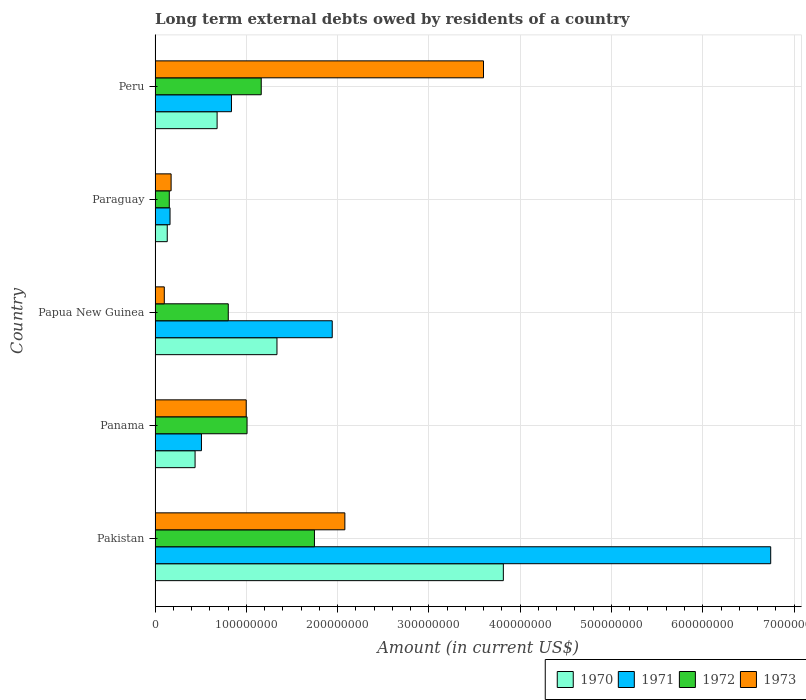How many different coloured bars are there?
Your answer should be very brief. 4. How many bars are there on the 3rd tick from the top?
Provide a succinct answer. 4. How many bars are there on the 3rd tick from the bottom?
Provide a succinct answer. 4. What is the label of the 2nd group of bars from the top?
Your response must be concise. Paraguay. What is the amount of long-term external debts owed by residents in 1973 in Paraguay?
Give a very brief answer. 1.76e+07. Across all countries, what is the maximum amount of long-term external debts owed by residents in 1970?
Give a very brief answer. 3.82e+08. Across all countries, what is the minimum amount of long-term external debts owed by residents in 1973?
Your answer should be compact. 1.01e+07. In which country was the amount of long-term external debts owed by residents in 1973 maximum?
Provide a succinct answer. Peru. In which country was the amount of long-term external debts owed by residents in 1972 minimum?
Your answer should be very brief. Paraguay. What is the total amount of long-term external debts owed by residents in 1972 in the graph?
Give a very brief answer. 4.87e+08. What is the difference between the amount of long-term external debts owed by residents in 1970 in Panama and that in Peru?
Your response must be concise. -2.41e+07. What is the difference between the amount of long-term external debts owed by residents in 1973 in Paraguay and the amount of long-term external debts owed by residents in 1972 in Pakistan?
Your response must be concise. -1.57e+08. What is the average amount of long-term external debts owed by residents in 1970 per country?
Provide a succinct answer. 1.28e+08. What is the difference between the amount of long-term external debts owed by residents in 1970 and amount of long-term external debts owed by residents in 1972 in Peru?
Keep it short and to the point. -4.83e+07. In how many countries, is the amount of long-term external debts owed by residents in 1973 greater than 380000000 US$?
Make the answer very short. 0. What is the ratio of the amount of long-term external debts owed by residents in 1970 in Panama to that in Peru?
Give a very brief answer. 0.64. Is the amount of long-term external debts owed by residents in 1970 in Panama less than that in Paraguay?
Offer a very short reply. No. Is the difference between the amount of long-term external debts owed by residents in 1970 in Pakistan and Papua New Guinea greater than the difference between the amount of long-term external debts owed by residents in 1972 in Pakistan and Papua New Guinea?
Provide a short and direct response. Yes. What is the difference between the highest and the second highest amount of long-term external debts owed by residents in 1971?
Your response must be concise. 4.80e+08. What is the difference between the highest and the lowest amount of long-term external debts owed by residents in 1970?
Offer a terse response. 3.68e+08. What does the 3rd bar from the top in Panama represents?
Provide a succinct answer. 1971. What does the 1st bar from the bottom in Paraguay represents?
Offer a very short reply. 1970. Are all the bars in the graph horizontal?
Offer a very short reply. Yes. What is the difference between two consecutive major ticks on the X-axis?
Make the answer very short. 1.00e+08. Does the graph contain any zero values?
Your answer should be very brief. No. Does the graph contain grids?
Offer a terse response. Yes. Where does the legend appear in the graph?
Offer a terse response. Bottom right. How many legend labels are there?
Your response must be concise. 4. How are the legend labels stacked?
Offer a terse response. Horizontal. What is the title of the graph?
Your answer should be very brief. Long term external debts owed by residents of a country. What is the label or title of the X-axis?
Provide a succinct answer. Amount (in current US$). What is the label or title of the Y-axis?
Make the answer very short. Country. What is the Amount (in current US$) in 1970 in Pakistan?
Provide a succinct answer. 3.82e+08. What is the Amount (in current US$) in 1971 in Pakistan?
Give a very brief answer. 6.74e+08. What is the Amount (in current US$) of 1972 in Pakistan?
Offer a very short reply. 1.75e+08. What is the Amount (in current US$) of 1973 in Pakistan?
Ensure brevity in your answer.  2.08e+08. What is the Amount (in current US$) in 1970 in Panama?
Provide a short and direct response. 4.38e+07. What is the Amount (in current US$) of 1971 in Panama?
Keep it short and to the point. 5.08e+07. What is the Amount (in current US$) in 1972 in Panama?
Give a very brief answer. 1.01e+08. What is the Amount (in current US$) in 1973 in Panama?
Your answer should be compact. 9.99e+07. What is the Amount (in current US$) in 1970 in Papua New Guinea?
Offer a very short reply. 1.34e+08. What is the Amount (in current US$) of 1971 in Papua New Guinea?
Your answer should be very brief. 1.94e+08. What is the Amount (in current US$) of 1972 in Papua New Guinea?
Your answer should be compact. 8.02e+07. What is the Amount (in current US$) in 1973 in Papua New Guinea?
Offer a very short reply. 1.01e+07. What is the Amount (in current US$) in 1970 in Paraguay?
Your answer should be compact. 1.34e+07. What is the Amount (in current US$) in 1971 in Paraguay?
Offer a terse response. 1.64e+07. What is the Amount (in current US$) of 1972 in Paraguay?
Provide a short and direct response. 1.56e+07. What is the Amount (in current US$) in 1973 in Paraguay?
Ensure brevity in your answer.  1.76e+07. What is the Amount (in current US$) of 1970 in Peru?
Your answer should be very brief. 6.80e+07. What is the Amount (in current US$) in 1971 in Peru?
Provide a succinct answer. 8.37e+07. What is the Amount (in current US$) of 1972 in Peru?
Your answer should be compact. 1.16e+08. What is the Amount (in current US$) of 1973 in Peru?
Offer a terse response. 3.60e+08. Across all countries, what is the maximum Amount (in current US$) of 1970?
Give a very brief answer. 3.82e+08. Across all countries, what is the maximum Amount (in current US$) of 1971?
Your response must be concise. 6.74e+08. Across all countries, what is the maximum Amount (in current US$) of 1972?
Give a very brief answer. 1.75e+08. Across all countries, what is the maximum Amount (in current US$) of 1973?
Provide a short and direct response. 3.60e+08. Across all countries, what is the minimum Amount (in current US$) of 1970?
Your answer should be very brief. 1.34e+07. Across all countries, what is the minimum Amount (in current US$) in 1971?
Offer a terse response. 1.64e+07. Across all countries, what is the minimum Amount (in current US$) of 1972?
Keep it short and to the point. 1.56e+07. Across all countries, what is the minimum Amount (in current US$) in 1973?
Offer a very short reply. 1.01e+07. What is the total Amount (in current US$) in 1970 in the graph?
Your answer should be compact. 6.40e+08. What is the total Amount (in current US$) in 1971 in the graph?
Keep it short and to the point. 1.02e+09. What is the total Amount (in current US$) of 1972 in the graph?
Provide a short and direct response. 4.87e+08. What is the total Amount (in current US$) of 1973 in the graph?
Offer a very short reply. 6.95e+08. What is the difference between the Amount (in current US$) of 1970 in Pakistan and that in Panama?
Offer a terse response. 3.38e+08. What is the difference between the Amount (in current US$) of 1971 in Pakistan and that in Panama?
Keep it short and to the point. 6.24e+08. What is the difference between the Amount (in current US$) in 1972 in Pakistan and that in Panama?
Your response must be concise. 7.38e+07. What is the difference between the Amount (in current US$) in 1973 in Pakistan and that in Panama?
Provide a succinct answer. 1.08e+08. What is the difference between the Amount (in current US$) in 1970 in Pakistan and that in Papua New Guinea?
Ensure brevity in your answer.  2.48e+08. What is the difference between the Amount (in current US$) of 1971 in Pakistan and that in Papua New Guinea?
Keep it short and to the point. 4.80e+08. What is the difference between the Amount (in current US$) in 1972 in Pakistan and that in Papua New Guinea?
Keep it short and to the point. 9.44e+07. What is the difference between the Amount (in current US$) of 1973 in Pakistan and that in Papua New Guinea?
Your response must be concise. 1.98e+08. What is the difference between the Amount (in current US$) of 1970 in Pakistan and that in Paraguay?
Your answer should be very brief. 3.68e+08. What is the difference between the Amount (in current US$) in 1971 in Pakistan and that in Paraguay?
Ensure brevity in your answer.  6.58e+08. What is the difference between the Amount (in current US$) in 1972 in Pakistan and that in Paraguay?
Give a very brief answer. 1.59e+08. What is the difference between the Amount (in current US$) of 1973 in Pakistan and that in Paraguay?
Your answer should be very brief. 1.90e+08. What is the difference between the Amount (in current US$) of 1970 in Pakistan and that in Peru?
Provide a short and direct response. 3.14e+08. What is the difference between the Amount (in current US$) in 1971 in Pakistan and that in Peru?
Ensure brevity in your answer.  5.91e+08. What is the difference between the Amount (in current US$) in 1972 in Pakistan and that in Peru?
Make the answer very short. 5.83e+07. What is the difference between the Amount (in current US$) of 1973 in Pakistan and that in Peru?
Your answer should be compact. -1.52e+08. What is the difference between the Amount (in current US$) in 1970 in Panama and that in Papua New Guinea?
Your response must be concise. -8.97e+07. What is the difference between the Amount (in current US$) of 1971 in Panama and that in Papua New Guinea?
Your response must be concise. -1.43e+08. What is the difference between the Amount (in current US$) of 1972 in Panama and that in Papua New Guinea?
Keep it short and to the point. 2.06e+07. What is the difference between the Amount (in current US$) of 1973 in Panama and that in Papua New Guinea?
Give a very brief answer. 8.97e+07. What is the difference between the Amount (in current US$) in 1970 in Panama and that in Paraguay?
Make the answer very short. 3.05e+07. What is the difference between the Amount (in current US$) in 1971 in Panama and that in Paraguay?
Make the answer very short. 3.44e+07. What is the difference between the Amount (in current US$) in 1972 in Panama and that in Paraguay?
Provide a succinct answer. 8.52e+07. What is the difference between the Amount (in current US$) in 1973 in Panama and that in Paraguay?
Provide a short and direct response. 8.23e+07. What is the difference between the Amount (in current US$) in 1970 in Panama and that in Peru?
Provide a succinct answer. -2.41e+07. What is the difference between the Amount (in current US$) in 1971 in Panama and that in Peru?
Make the answer very short. -3.29e+07. What is the difference between the Amount (in current US$) in 1972 in Panama and that in Peru?
Your response must be concise. -1.56e+07. What is the difference between the Amount (in current US$) in 1973 in Panama and that in Peru?
Give a very brief answer. -2.60e+08. What is the difference between the Amount (in current US$) of 1970 in Papua New Guinea and that in Paraguay?
Your answer should be compact. 1.20e+08. What is the difference between the Amount (in current US$) in 1971 in Papua New Guinea and that in Paraguay?
Offer a terse response. 1.78e+08. What is the difference between the Amount (in current US$) of 1972 in Papua New Guinea and that in Paraguay?
Keep it short and to the point. 6.46e+07. What is the difference between the Amount (in current US$) in 1973 in Papua New Guinea and that in Paraguay?
Your response must be concise. -7.47e+06. What is the difference between the Amount (in current US$) in 1970 in Papua New Guinea and that in Peru?
Make the answer very short. 6.56e+07. What is the difference between the Amount (in current US$) in 1971 in Papua New Guinea and that in Peru?
Provide a succinct answer. 1.10e+08. What is the difference between the Amount (in current US$) of 1972 in Papua New Guinea and that in Peru?
Provide a succinct answer. -3.61e+07. What is the difference between the Amount (in current US$) of 1973 in Papua New Guinea and that in Peru?
Provide a succinct answer. -3.50e+08. What is the difference between the Amount (in current US$) of 1970 in Paraguay and that in Peru?
Make the answer very short. -5.46e+07. What is the difference between the Amount (in current US$) of 1971 in Paraguay and that in Peru?
Give a very brief answer. -6.73e+07. What is the difference between the Amount (in current US$) of 1972 in Paraguay and that in Peru?
Offer a very short reply. -1.01e+08. What is the difference between the Amount (in current US$) in 1973 in Paraguay and that in Peru?
Your response must be concise. -3.42e+08. What is the difference between the Amount (in current US$) of 1970 in Pakistan and the Amount (in current US$) of 1971 in Panama?
Make the answer very short. 3.31e+08. What is the difference between the Amount (in current US$) in 1970 in Pakistan and the Amount (in current US$) in 1972 in Panama?
Your response must be concise. 2.81e+08. What is the difference between the Amount (in current US$) of 1970 in Pakistan and the Amount (in current US$) of 1973 in Panama?
Offer a very short reply. 2.82e+08. What is the difference between the Amount (in current US$) in 1971 in Pakistan and the Amount (in current US$) in 1972 in Panama?
Give a very brief answer. 5.74e+08. What is the difference between the Amount (in current US$) in 1971 in Pakistan and the Amount (in current US$) in 1973 in Panama?
Provide a succinct answer. 5.75e+08. What is the difference between the Amount (in current US$) of 1972 in Pakistan and the Amount (in current US$) of 1973 in Panama?
Your response must be concise. 7.47e+07. What is the difference between the Amount (in current US$) in 1970 in Pakistan and the Amount (in current US$) in 1971 in Papua New Guinea?
Keep it short and to the point. 1.87e+08. What is the difference between the Amount (in current US$) in 1970 in Pakistan and the Amount (in current US$) in 1972 in Papua New Guinea?
Provide a succinct answer. 3.01e+08. What is the difference between the Amount (in current US$) of 1970 in Pakistan and the Amount (in current US$) of 1973 in Papua New Guinea?
Your answer should be compact. 3.71e+08. What is the difference between the Amount (in current US$) in 1971 in Pakistan and the Amount (in current US$) in 1972 in Papua New Guinea?
Offer a very short reply. 5.94e+08. What is the difference between the Amount (in current US$) of 1971 in Pakistan and the Amount (in current US$) of 1973 in Papua New Guinea?
Provide a short and direct response. 6.64e+08. What is the difference between the Amount (in current US$) in 1972 in Pakistan and the Amount (in current US$) in 1973 in Papua New Guinea?
Provide a succinct answer. 1.64e+08. What is the difference between the Amount (in current US$) in 1970 in Pakistan and the Amount (in current US$) in 1971 in Paraguay?
Keep it short and to the point. 3.65e+08. What is the difference between the Amount (in current US$) in 1970 in Pakistan and the Amount (in current US$) in 1972 in Paraguay?
Offer a terse response. 3.66e+08. What is the difference between the Amount (in current US$) of 1970 in Pakistan and the Amount (in current US$) of 1973 in Paraguay?
Provide a succinct answer. 3.64e+08. What is the difference between the Amount (in current US$) of 1971 in Pakistan and the Amount (in current US$) of 1972 in Paraguay?
Your response must be concise. 6.59e+08. What is the difference between the Amount (in current US$) of 1971 in Pakistan and the Amount (in current US$) of 1973 in Paraguay?
Your answer should be very brief. 6.57e+08. What is the difference between the Amount (in current US$) of 1972 in Pakistan and the Amount (in current US$) of 1973 in Paraguay?
Provide a succinct answer. 1.57e+08. What is the difference between the Amount (in current US$) in 1970 in Pakistan and the Amount (in current US$) in 1971 in Peru?
Make the answer very short. 2.98e+08. What is the difference between the Amount (in current US$) in 1970 in Pakistan and the Amount (in current US$) in 1972 in Peru?
Provide a short and direct response. 2.65e+08. What is the difference between the Amount (in current US$) of 1970 in Pakistan and the Amount (in current US$) of 1973 in Peru?
Provide a short and direct response. 2.17e+07. What is the difference between the Amount (in current US$) of 1971 in Pakistan and the Amount (in current US$) of 1972 in Peru?
Keep it short and to the point. 5.58e+08. What is the difference between the Amount (in current US$) in 1971 in Pakistan and the Amount (in current US$) in 1973 in Peru?
Give a very brief answer. 3.15e+08. What is the difference between the Amount (in current US$) in 1972 in Pakistan and the Amount (in current US$) in 1973 in Peru?
Offer a very short reply. -1.85e+08. What is the difference between the Amount (in current US$) in 1970 in Panama and the Amount (in current US$) in 1971 in Papua New Guinea?
Ensure brevity in your answer.  -1.50e+08. What is the difference between the Amount (in current US$) in 1970 in Panama and the Amount (in current US$) in 1972 in Papua New Guinea?
Your answer should be compact. -3.64e+07. What is the difference between the Amount (in current US$) in 1970 in Panama and the Amount (in current US$) in 1973 in Papua New Guinea?
Your answer should be very brief. 3.37e+07. What is the difference between the Amount (in current US$) in 1971 in Panama and the Amount (in current US$) in 1972 in Papua New Guinea?
Provide a short and direct response. -2.94e+07. What is the difference between the Amount (in current US$) in 1971 in Panama and the Amount (in current US$) in 1973 in Papua New Guinea?
Make the answer very short. 4.07e+07. What is the difference between the Amount (in current US$) of 1972 in Panama and the Amount (in current US$) of 1973 in Papua New Guinea?
Provide a succinct answer. 9.06e+07. What is the difference between the Amount (in current US$) in 1970 in Panama and the Amount (in current US$) in 1971 in Paraguay?
Keep it short and to the point. 2.74e+07. What is the difference between the Amount (in current US$) of 1970 in Panama and the Amount (in current US$) of 1972 in Paraguay?
Make the answer very short. 2.82e+07. What is the difference between the Amount (in current US$) in 1970 in Panama and the Amount (in current US$) in 1973 in Paraguay?
Offer a terse response. 2.62e+07. What is the difference between the Amount (in current US$) in 1971 in Panama and the Amount (in current US$) in 1972 in Paraguay?
Give a very brief answer. 3.52e+07. What is the difference between the Amount (in current US$) of 1971 in Panama and the Amount (in current US$) of 1973 in Paraguay?
Make the answer very short. 3.32e+07. What is the difference between the Amount (in current US$) in 1972 in Panama and the Amount (in current US$) in 1973 in Paraguay?
Keep it short and to the point. 8.32e+07. What is the difference between the Amount (in current US$) of 1970 in Panama and the Amount (in current US$) of 1971 in Peru?
Ensure brevity in your answer.  -3.99e+07. What is the difference between the Amount (in current US$) in 1970 in Panama and the Amount (in current US$) in 1972 in Peru?
Your answer should be very brief. -7.25e+07. What is the difference between the Amount (in current US$) in 1970 in Panama and the Amount (in current US$) in 1973 in Peru?
Your answer should be compact. -3.16e+08. What is the difference between the Amount (in current US$) of 1971 in Panama and the Amount (in current US$) of 1972 in Peru?
Offer a terse response. -6.55e+07. What is the difference between the Amount (in current US$) of 1971 in Panama and the Amount (in current US$) of 1973 in Peru?
Your answer should be compact. -3.09e+08. What is the difference between the Amount (in current US$) in 1972 in Panama and the Amount (in current US$) in 1973 in Peru?
Your answer should be compact. -2.59e+08. What is the difference between the Amount (in current US$) of 1970 in Papua New Guinea and the Amount (in current US$) of 1971 in Paraguay?
Provide a succinct answer. 1.17e+08. What is the difference between the Amount (in current US$) in 1970 in Papua New Guinea and the Amount (in current US$) in 1972 in Paraguay?
Your response must be concise. 1.18e+08. What is the difference between the Amount (in current US$) of 1970 in Papua New Guinea and the Amount (in current US$) of 1973 in Paraguay?
Your response must be concise. 1.16e+08. What is the difference between the Amount (in current US$) in 1971 in Papua New Guinea and the Amount (in current US$) in 1972 in Paraguay?
Keep it short and to the point. 1.78e+08. What is the difference between the Amount (in current US$) of 1971 in Papua New Guinea and the Amount (in current US$) of 1973 in Paraguay?
Give a very brief answer. 1.77e+08. What is the difference between the Amount (in current US$) in 1972 in Papua New Guinea and the Amount (in current US$) in 1973 in Paraguay?
Offer a very short reply. 6.26e+07. What is the difference between the Amount (in current US$) of 1970 in Papua New Guinea and the Amount (in current US$) of 1971 in Peru?
Make the answer very short. 4.98e+07. What is the difference between the Amount (in current US$) in 1970 in Papua New Guinea and the Amount (in current US$) in 1972 in Peru?
Make the answer very short. 1.72e+07. What is the difference between the Amount (in current US$) of 1970 in Papua New Guinea and the Amount (in current US$) of 1973 in Peru?
Offer a terse response. -2.26e+08. What is the difference between the Amount (in current US$) of 1971 in Papua New Guinea and the Amount (in current US$) of 1972 in Peru?
Provide a short and direct response. 7.78e+07. What is the difference between the Amount (in current US$) in 1971 in Papua New Guinea and the Amount (in current US$) in 1973 in Peru?
Offer a terse response. -1.66e+08. What is the difference between the Amount (in current US$) of 1972 in Papua New Guinea and the Amount (in current US$) of 1973 in Peru?
Offer a terse response. -2.80e+08. What is the difference between the Amount (in current US$) in 1970 in Paraguay and the Amount (in current US$) in 1971 in Peru?
Ensure brevity in your answer.  -7.03e+07. What is the difference between the Amount (in current US$) of 1970 in Paraguay and the Amount (in current US$) of 1972 in Peru?
Ensure brevity in your answer.  -1.03e+08. What is the difference between the Amount (in current US$) in 1970 in Paraguay and the Amount (in current US$) in 1973 in Peru?
Your answer should be compact. -3.46e+08. What is the difference between the Amount (in current US$) of 1971 in Paraguay and the Amount (in current US$) of 1972 in Peru?
Offer a very short reply. -9.99e+07. What is the difference between the Amount (in current US$) of 1971 in Paraguay and the Amount (in current US$) of 1973 in Peru?
Your response must be concise. -3.43e+08. What is the difference between the Amount (in current US$) of 1972 in Paraguay and the Amount (in current US$) of 1973 in Peru?
Offer a terse response. -3.44e+08. What is the average Amount (in current US$) of 1970 per country?
Provide a succinct answer. 1.28e+08. What is the average Amount (in current US$) of 1971 per country?
Ensure brevity in your answer.  2.04e+08. What is the average Amount (in current US$) of 1972 per country?
Keep it short and to the point. 9.75e+07. What is the average Amount (in current US$) of 1973 per country?
Keep it short and to the point. 1.39e+08. What is the difference between the Amount (in current US$) of 1970 and Amount (in current US$) of 1971 in Pakistan?
Provide a succinct answer. -2.93e+08. What is the difference between the Amount (in current US$) in 1970 and Amount (in current US$) in 1972 in Pakistan?
Your answer should be very brief. 2.07e+08. What is the difference between the Amount (in current US$) in 1970 and Amount (in current US$) in 1973 in Pakistan?
Your answer should be compact. 1.74e+08. What is the difference between the Amount (in current US$) of 1971 and Amount (in current US$) of 1972 in Pakistan?
Your answer should be very brief. 5.00e+08. What is the difference between the Amount (in current US$) in 1971 and Amount (in current US$) in 1973 in Pakistan?
Offer a very short reply. 4.67e+08. What is the difference between the Amount (in current US$) of 1972 and Amount (in current US$) of 1973 in Pakistan?
Your answer should be compact. -3.33e+07. What is the difference between the Amount (in current US$) of 1970 and Amount (in current US$) of 1971 in Panama?
Make the answer very short. -6.98e+06. What is the difference between the Amount (in current US$) of 1970 and Amount (in current US$) of 1972 in Panama?
Provide a succinct answer. -5.69e+07. What is the difference between the Amount (in current US$) in 1970 and Amount (in current US$) in 1973 in Panama?
Provide a short and direct response. -5.60e+07. What is the difference between the Amount (in current US$) in 1971 and Amount (in current US$) in 1972 in Panama?
Give a very brief answer. -5.00e+07. What is the difference between the Amount (in current US$) of 1971 and Amount (in current US$) of 1973 in Panama?
Provide a short and direct response. -4.90e+07. What is the difference between the Amount (in current US$) of 1972 and Amount (in current US$) of 1973 in Panama?
Make the answer very short. 9.03e+05. What is the difference between the Amount (in current US$) in 1970 and Amount (in current US$) in 1971 in Papua New Guinea?
Your answer should be very brief. -6.05e+07. What is the difference between the Amount (in current US$) in 1970 and Amount (in current US$) in 1972 in Papua New Guinea?
Keep it short and to the point. 5.34e+07. What is the difference between the Amount (in current US$) in 1970 and Amount (in current US$) in 1973 in Papua New Guinea?
Your answer should be very brief. 1.23e+08. What is the difference between the Amount (in current US$) in 1971 and Amount (in current US$) in 1972 in Papua New Guinea?
Provide a short and direct response. 1.14e+08. What is the difference between the Amount (in current US$) of 1971 and Amount (in current US$) of 1973 in Papua New Guinea?
Your response must be concise. 1.84e+08. What is the difference between the Amount (in current US$) in 1972 and Amount (in current US$) in 1973 in Papua New Guinea?
Give a very brief answer. 7.01e+07. What is the difference between the Amount (in current US$) of 1970 and Amount (in current US$) of 1971 in Paraguay?
Offer a very short reply. -3.05e+06. What is the difference between the Amount (in current US$) of 1970 and Amount (in current US$) of 1972 in Paraguay?
Provide a short and direct response. -2.23e+06. What is the difference between the Amount (in current US$) in 1970 and Amount (in current US$) in 1973 in Paraguay?
Provide a short and direct response. -4.23e+06. What is the difference between the Amount (in current US$) in 1971 and Amount (in current US$) in 1972 in Paraguay?
Your answer should be compact. 8.15e+05. What is the difference between the Amount (in current US$) of 1971 and Amount (in current US$) of 1973 in Paraguay?
Provide a succinct answer. -1.18e+06. What is the difference between the Amount (in current US$) in 1972 and Amount (in current US$) in 1973 in Paraguay?
Your answer should be very brief. -2.00e+06. What is the difference between the Amount (in current US$) in 1970 and Amount (in current US$) in 1971 in Peru?
Your answer should be compact. -1.57e+07. What is the difference between the Amount (in current US$) of 1970 and Amount (in current US$) of 1972 in Peru?
Offer a terse response. -4.83e+07. What is the difference between the Amount (in current US$) of 1970 and Amount (in current US$) of 1973 in Peru?
Provide a short and direct response. -2.92e+08. What is the difference between the Amount (in current US$) of 1971 and Amount (in current US$) of 1972 in Peru?
Your response must be concise. -3.26e+07. What is the difference between the Amount (in current US$) in 1971 and Amount (in current US$) in 1973 in Peru?
Keep it short and to the point. -2.76e+08. What is the difference between the Amount (in current US$) of 1972 and Amount (in current US$) of 1973 in Peru?
Your response must be concise. -2.43e+08. What is the ratio of the Amount (in current US$) in 1970 in Pakistan to that in Panama?
Make the answer very short. 8.7. What is the ratio of the Amount (in current US$) in 1971 in Pakistan to that in Panama?
Your answer should be very brief. 13.27. What is the ratio of the Amount (in current US$) of 1972 in Pakistan to that in Panama?
Provide a short and direct response. 1.73. What is the ratio of the Amount (in current US$) of 1973 in Pakistan to that in Panama?
Make the answer very short. 2.08. What is the ratio of the Amount (in current US$) in 1970 in Pakistan to that in Papua New Guinea?
Your response must be concise. 2.86. What is the ratio of the Amount (in current US$) of 1971 in Pakistan to that in Papua New Guinea?
Offer a very short reply. 3.48. What is the ratio of the Amount (in current US$) in 1972 in Pakistan to that in Papua New Guinea?
Offer a terse response. 2.18. What is the ratio of the Amount (in current US$) of 1973 in Pakistan to that in Papua New Guinea?
Offer a very short reply. 20.55. What is the ratio of the Amount (in current US$) of 1970 in Pakistan to that in Paraguay?
Give a very brief answer. 28.56. What is the ratio of the Amount (in current US$) in 1971 in Pakistan to that in Paraguay?
Keep it short and to the point. 41.11. What is the ratio of the Amount (in current US$) of 1972 in Pakistan to that in Paraguay?
Your answer should be very brief. 11.2. What is the ratio of the Amount (in current US$) of 1973 in Pakistan to that in Paraguay?
Ensure brevity in your answer.  11.82. What is the ratio of the Amount (in current US$) of 1970 in Pakistan to that in Peru?
Your answer should be compact. 5.61. What is the ratio of the Amount (in current US$) in 1971 in Pakistan to that in Peru?
Offer a terse response. 8.06. What is the ratio of the Amount (in current US$) in 1972 in Pakistan to that in Peru?
Your response must be concise. 1.5. What is the ratio of the Amount (in current US$) of 1973 in Pakistan to that in Peru?
Provide a succinct answer. 0.58. What is the ratio of the Amount (in current US$) of 1970 in Panama to that in Papua New Guinea?
Make the answer very short. 0.33. What is the ratio of the Amount (in current US$) of 1971 in Panama to that in Papua New Guinea?
Your answer should be compact. 0.26. What is the ratio of the Amount (in current US$) in 1972 in Panama to that in Papua New Guinea?
Give a very brief answer. 1.26. What is the ratio of the Amount (in current US$) in 1973 in Panama to that in Papua New Guinea?
Provide a succinct answer. 9.87. What is the ratio of the Amount (in current US$) of 1970 in Panama to that in Paraguay?
Your answer should be very brief. 3.28. What is the ratio of the Amount (in current US$) in 1971 in Panama to that in Paraguay?
Keep it short and to the point. 3.1. What is the ratio of the Amount (in current US$) in 1972 in Panama to that in Paraguay?
Keep it short and to the point. 6.46. What is the ratio of the Amount (in current US$) in 1973 in Panama to that in Paraguay?
Your answer should be compact. 5.68. What is the ratio of the Amount (in current US$) of 1970 in Panama to that in Peru?
Your answer should be very brief. 0.64. What is the ratio of the Amount (in current US$) of 1971 in Panama to that in Peru?
Offer a very short reply. 0.61. What is the ratio of the Amount (in current US$) in 1972 in Panama to that in Peru?
Give a very brief answer. 0.87. What is the ratio of the Amount (in current US$) in 1973 in Panama to that in Peru?
Keep it short and to the point. 0.28. What is the ratio of the Amount (in current US$) in 1970 in Papua New Guinea to that in Paraguay?
Your answer should be very brief. 10. What is the ratio of the Amount (in current US$) in 1971 in Papua New Guinea to that in Paraguay?
Your answer should be very brief. 11.83. What is the ratio of the Amount (in current US$) in 1972 in Papua New Guinea to that in Paraguay?
Offer a very short reply. 5.14. What is the ratio of the Amount (in current US$) in 1973 in Papua New Guinea to that in Paraguay?
Your answer should be very brief. 0.58. What is the ratio of the Amount (in current US$) in 1970 in Papua New Guinea to that in Peru?
Ensure brevity in your answer.  1.96. What is the ratio of the Amount (in current US$) in 1971 in Papua New Guinea to that in Peru?
Offer a very short reply. 2.32. What is the ratio of the Amount (in current US$) in 1972 in Papua New Guinea to that in Peru?
Give a very brief answer. 0.69. What is the ratio of the Amount (in current US$) in 1973 in Papua New Guinea to that in Peru?
Offer a terse response. 0.03. What is the ratio of the Amount (in current US$) in 1970 in Paraguay to that in Peru?
Ensure brevity in your answer.  0.2. What is the ratio of the Amount (in current US$) of 1971 in Paraguay to that in Peru?
Offer a very short reply. 0.2. What is the ratio of the Amount (in current US$) of 1972 in Paraguay to that in Peru?
Ensure brevity in your answer.  0.13. What is the ratio of the Amount (in current US$) in 1973 in Paraguay to that in Peru?
Provide a succinct answer. 0.05. What is the difference between the highest and the second highest Amount (in current US$) in 1970?
Your answer should be compact. 2.48e+08. What is the difference between the highest and the second highest Amount (in current US$) of 1971?
Provide a succinct answer. 4.80e+08. What is the difference between the highest and the second highest Amount (in current US$) in 1972?
Provide a short and direct response. 5.83e+07. What is the difference between the highest and the second highest Amount (in current US$) in 1973?
Keep it short and to the point. 1.52e+08. What is the difference between the highest and the lowest Amount (in current US$) in 1970?
Give a very brief answer. 3.68e+08. What is the difference between the highest and the lowest Amount (in current US$) of 1971?
Ensure brevity in your answer.  6.58e+08. What is the difference between the highest and the lowest Amount (in current US$) of 1972?
Offer a very short reply. 1.59e+08. What is the difference between the highest and the lowest Amount (in current US$) in 1973?
Provide a succinct answer. 3.50e+08. 